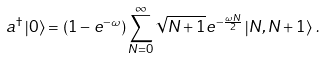<formula> <loc_0><loc_0><loc_500><loc_500>a ^ { \dagger } \left | 0 \right > = ( 1 - e ^ { - \omega } ) \sum _ { N = 0 } ^ { \infty } \sqrt { N + 1 } e ^ { - \frac { \omega N } { 2 } } \left | N , N + 1 \right > \, .</formula> 